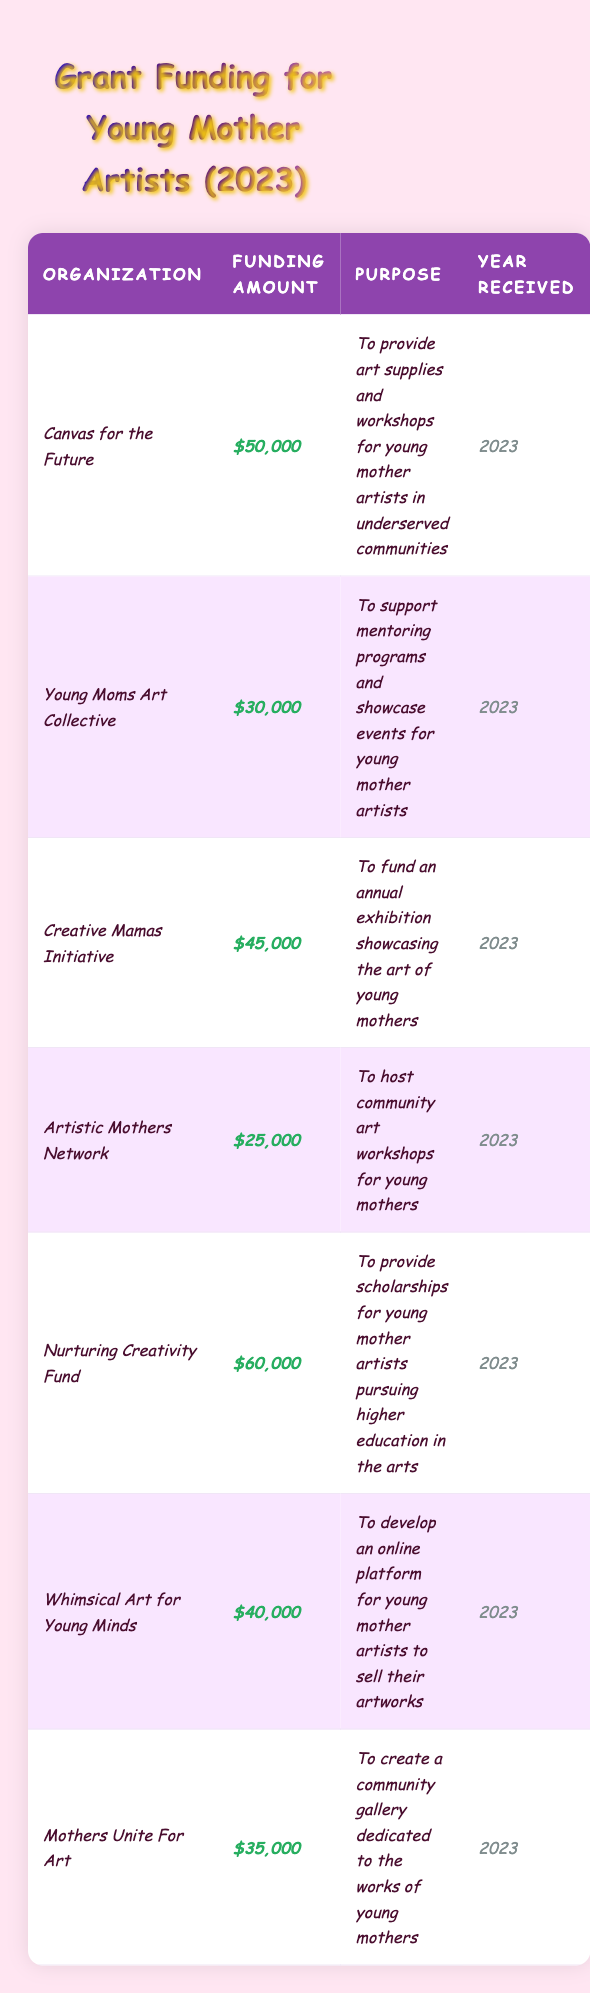What is the total grant funding received by all organizations listed? To find the total grant funding, add together the amounts from each organization: $50,000 + $30,000 + $45,000 + $25,000 + $60,000 + $40,000 + $35,000 = $285,000.
Answer: $285,000 Which organization received the highest grant funding? Looking at the funding amounts, $60,000 from the Nurturing Creativity Fund is the highest compared to the others: $50,000, $30,000, $45,000, $25,000, $40,000, and $35,000.
Answer: Nurturing Creativity Fund How many organizations received funding of $40,000 or more? The organizations with $40,000 or more are: Nurturing Creativity Fund ($60,000), Canvas for the Future ($50,000), Creative Mamas Initiative ($45,000), and Whimsical Art for Young Minds ($40,000). This totals four organizations.
Answer: 4 Did any organization receive exactly $30,000 in funding? The Young Moms Art Collective received exactly $30,000 in funding, which can be seen explicitly in the table.
Answer: Yes What is the average funding amount for organizations supporting young mother artists? To calculate the average, first sum the total funding amounts, which is $285,000, and then divide by the number of organizations (7): $285,000 / 7 = $40,714.29.
Answer: $40,714.29 Which organization has a purpose related to scholarships for higher education? The organization that provides scholarships for young mother artists pursuing higher education in the arts is the Nurturing Creativity Fund, as stated in the purpose column.
Answer: Nurturing Creativity Fund How much less funding did the Artistic Mothers Network receive compared to the Nurturing Creativity Fund? To find the difference, subtract the funding of the Artistic Mothers Network ($25,000) from that of the Nurturing Creativity Fund ($60,000): $60,000 - $25,000 = $35,000.
Answer: $35,000 Is the total funding of all organizations in the table more than $250,000? Since the total funding is $285,000, which is greater than $250,000, the statement is true based on the summed amounts from each organization.
Answer: Yes Which organization focuses specifically on developing an online platform for young mothers to sell art? The organization designated to develop an online platform for young mother artists to sell their artworks is Whimsical Art for Young Minds, as indicated in the table.
Answer: Whimsical Art for Young Minds If we exclude the organization with the lowest funding, what will be the new average funding amount? The lowest funding is $25,000 from the Artistic Mothers Network. We subtract it from the total ($285,000) to get $260,000 for the remaining 6 organizations: $260,000 / 6 = $43,333.33.
Answer: $43,333.33 